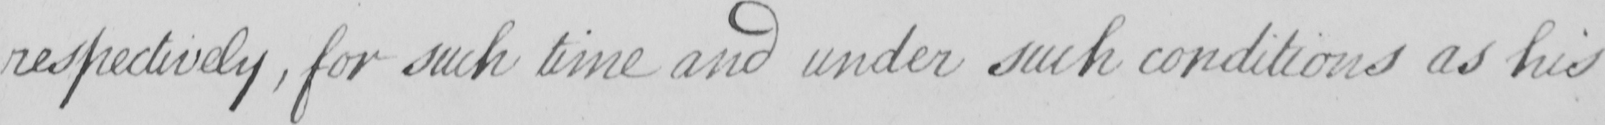Transcribe the text shown in this historical manuscript line. respectively , for such time and under such conditions as his 